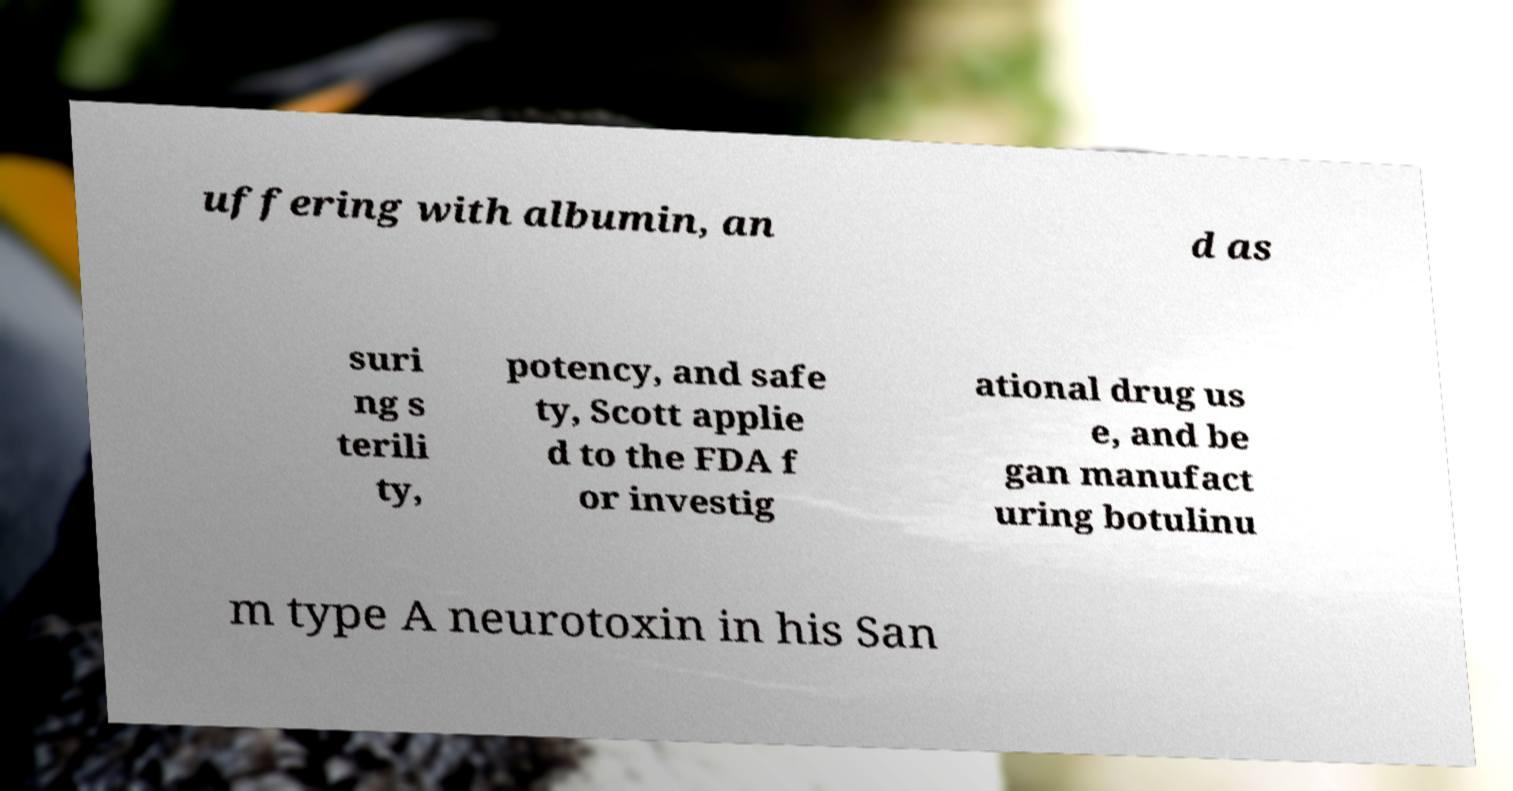Please read and relay the text visible in this image. What does it say? uffering with albumin, an d as suri ng s terili ty, potency, and safe ty, Scott applie d to the FDA f or investig ational drug us e, and be gan manufact uring botulinu m type A neurotoxin in his San 